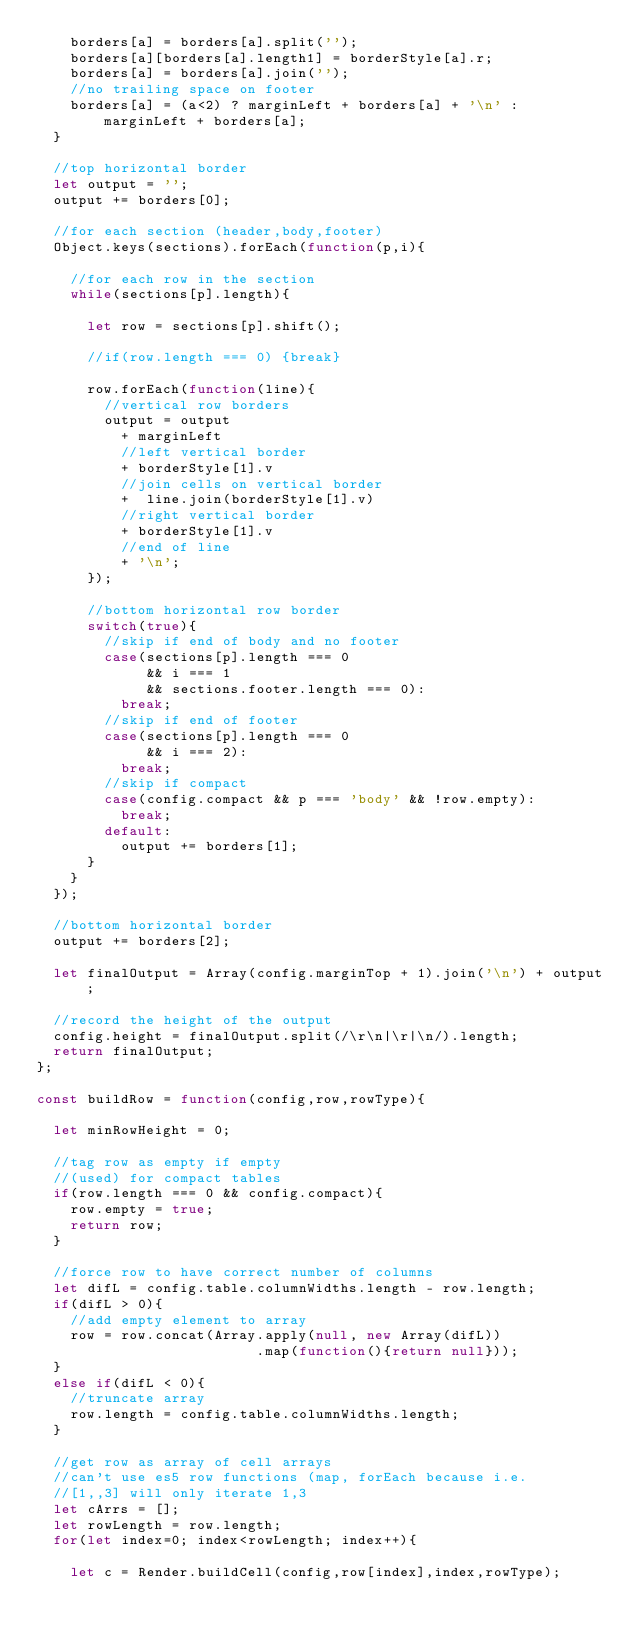Convert code to text. <code><loc_0><loc_0><loc_500><loc_500><_JavaScript_>    borders[a] = borders[a].split('');
    borders[a][borders[a].length1] = borderStyle[a].r;
    borders[a] = borders[a].join('');
    //no trailing space on footer
    borders[a] = (a<2) ? marginLeft + borders[a] + '\n' : marginLeft + borders[a];
  }
  
  //top horizontal border
  let output = '';
  output += borders[0];

  //for each section (header,body,footer)
  Object.keys(sections).forEach(function(p,i){
    
    //for each row in the section
    while(sections[p].length){
      
      let row = sections[p].shift();
      
      //if(row.length === 0) {break}

      row.forEach(function(line){
        //vertical row borders
        output = output 
          + marginLeft 
          //left vertical border
          + borderStyle[1].v 
          //join cells on vertical border
          +  line.join(borderStyle[1].v) 
          //right vertical border
          + borderStyle[1].v
          //end of line
          + '\n';
      });
    
      //bottom horizontal row border
      switch(true){
        //skip if end of body and no footer
        case(sections[p].length === 0 
             && i === 1 
             && sections.footer.length === 0):
          break;
        //skip if end of footer
        case(sections[p].length === 0 
             && i === 2):
          break;
        //skip if compact
        case(config.compact && p === 'body' && !row.empty):
          break;
        default:
          output += borders[1];
      }  
    }
  });
  
  //bottom horizontal border
  output += borders[2];
 
  let finalOutput = Array(config.marginTop + 1).join('\n') + output;

  //record the height of the output
  config.height = finalOutput.split(/\r\n|\r|\n/).length;
  return finalOutput;
};

const buildRow = function(config,row,rowType){
  
  let minRowHeight = 0;
  
  //tag row as empty if empty
  //(used) for compact tables
  if(row.length === 0 && config.compact){
    row.empty = true;
    return row;
  }

  //force row to have correct number of columns
  let difL = config.table.columnWidths.length - row.length;
  if(difL > 0){
    //add empty element to array
    row = row.concat(Array.apply(null, new Array(difL))
                          .map(function(){return null})); 
  }
  else if(difL < 0){
    //truncate array
    row.length = config.table.columnWidths.length;
  }
  
  //get row as array of cell arrays
  //can't use es5 row functions (map, forEach because i.e.
  //[1,,3] will only iterate 1,3
  let cArrs = [];
  let rowLength = row.length;
  for(let index=0; index<rowLength; index++){
    
    let c = Render.buildCell(config,row[index],index,rowType);</code> 